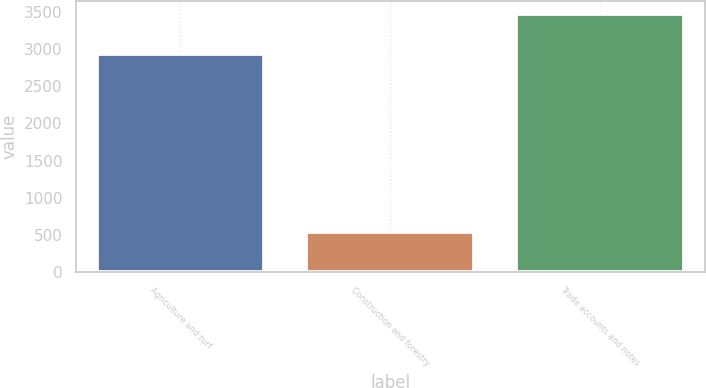Convert chart to OTSL. <chart><loc_0><loc_0><loc_500><loc_500><bar_chart><fcel>Agriculture and turf<fcel>Construction and forestry<fcel>Trade accounts and notes<nl><fcel>2929<fcel>535<fcel>3464<nl></chart> 